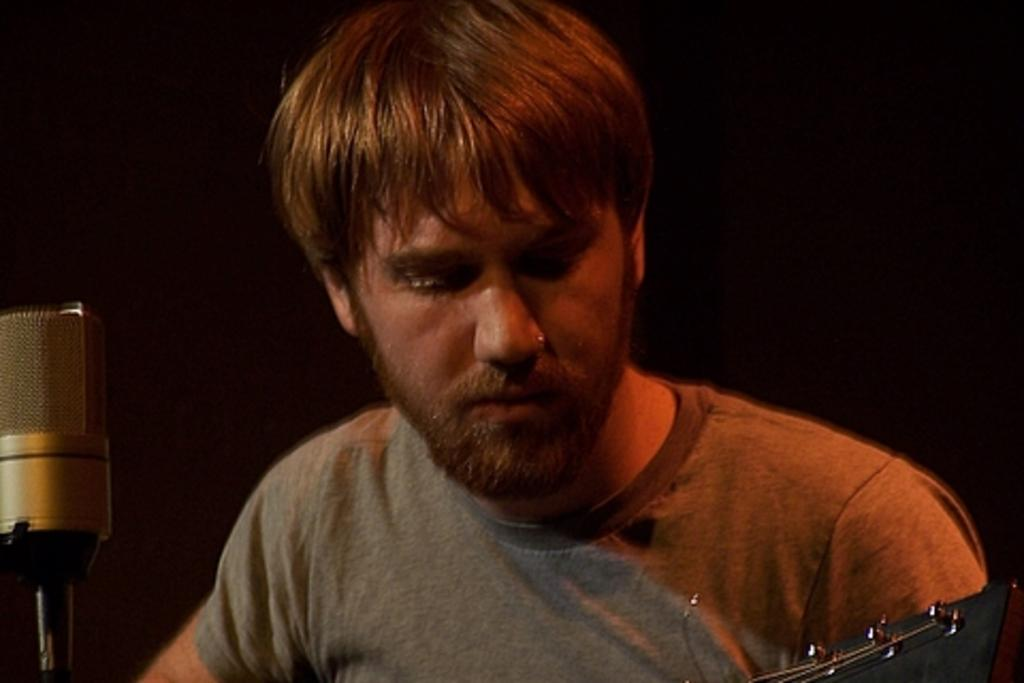Who is present in the image? There is a man in the image. What is the man holding in the image? The man is holding a musical instrument. What equipment is visible in the image for amplifying sound? There is a microphone with a stand in the image. What can be said about the lighting in the image? The background of the image is dark. How many pies are on the table in the image? There is no table or pies present in the image. What type of debt is the man discussing in the image? There is no mention of debt in the image; the man is holding a musical instrument. 